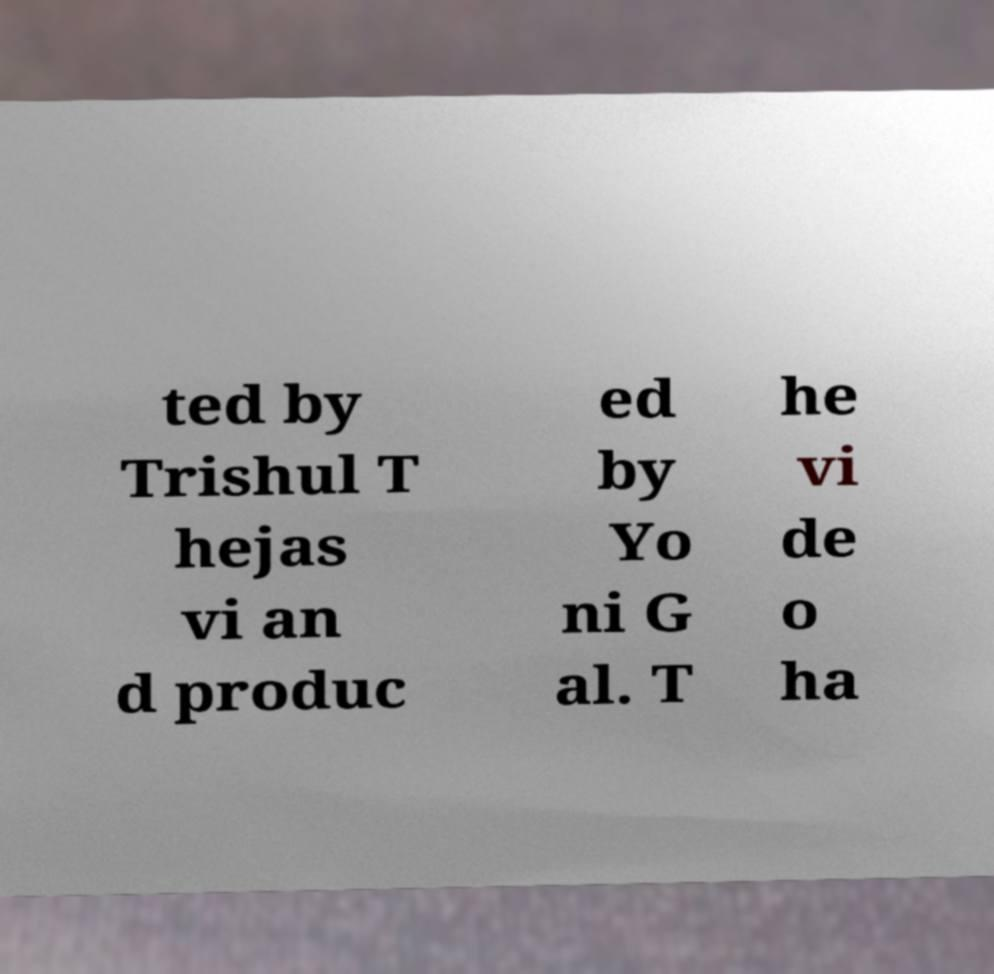Can you read and provide the text displayed in the image?This photo seems to have some interesting text. Can you extract and type it out for me? ted by Trishul T hejas vi an d produc ed by Yo ni G al. T he vi de o ha 